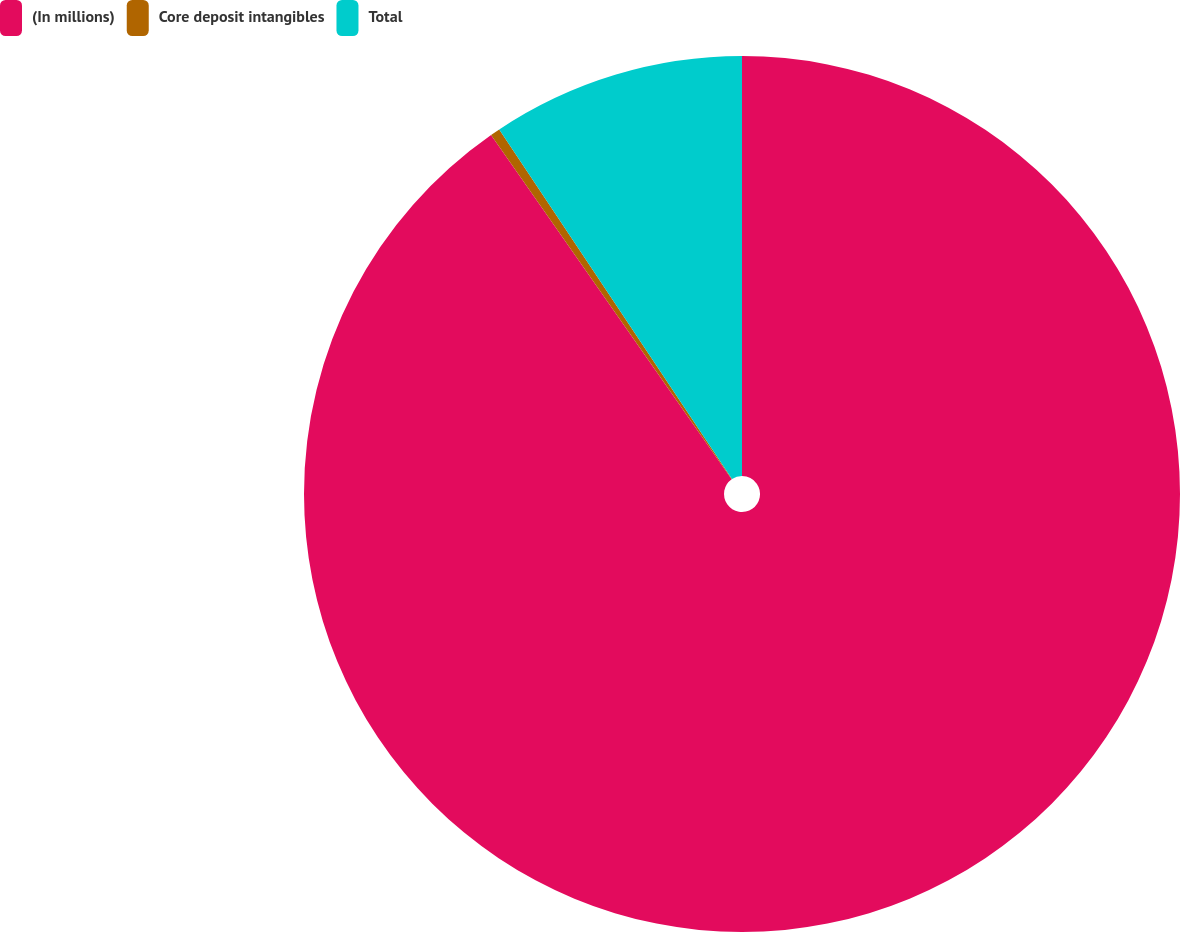Convert chart. <chart><loc_0><loc_0><loc_500><loc_500><pie_chart><fcel>(In millions)<fcel>Core deposit intangibles<fcel>Total<nl><fcel>90.29%<fcel>0.36%<fcel>9.35%<nl></chart> 